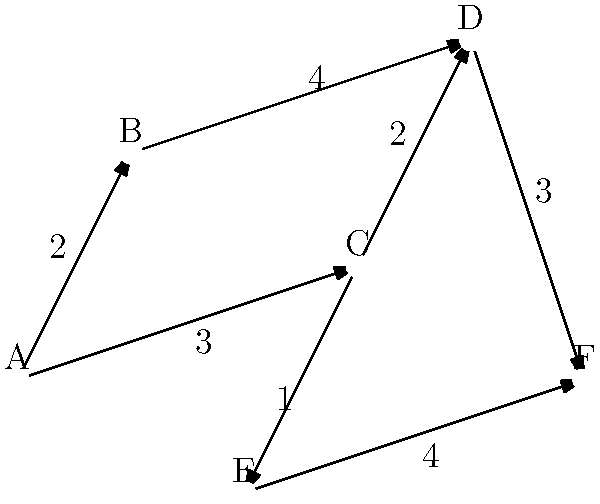In the graph above, each node represents a historical landmark of the Civil Rights Movement. The edges represent direct routes between landmarks, with the numbers indicating the travel time in hours. What is the shortest path from landmark A to landmark F, and what is the total travel time? To find the shortest path from A to F, we'll use Dijkstra's algorithm:

1. Start at node A with a distance of 0.
2. Explore neighbors of A:
   - B: distance 2
   - C: distance 3
3. Choose B (shortest distance). Explore its neighbors:
   - D: distance 2 + 4 = 6
4. Choose C (next shortest). Explore its neighbors:
   - D: distance 3 + 2 = 5 (shorter than previous path to D)
   - E: distance 3 + 1 = 4
5. Choose E (shortest unvisited). Explore its neighbor:
   - F: distance 4 + 4 = 8
6. Choose D (next shortest). Explore its neighbor:
   - F: distance 5 + 3 = 8 (tied with path through E)

The shortest path is A → C → D → F with a total travel time of 8 hours.

This path likely represents a journey through key Civil Rights Movement landmarks, potentially including locations like the Edmund Pettus Bridge in Selma (A), the 16th Street Baptist Church in Birmingham (C), the National Civil Rights Museum in Memphis (D), and the Martin Luther King Jr. National Historical Park in Atlanta (F).
Answer: A → C → D → F, 8 hours 